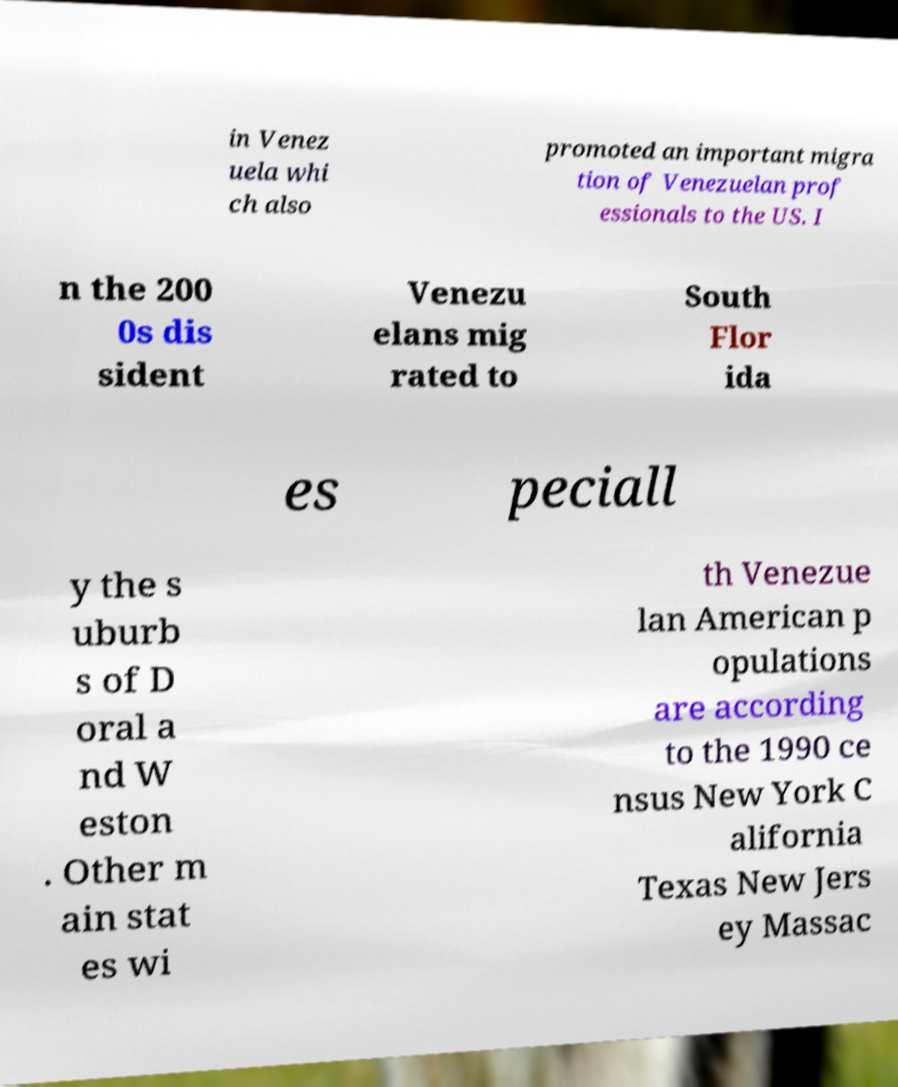What messages or text are displayed in this image? I need them in a readable, typed format. in Venez uela whi ch also promoted an important migra tion of Venezuelan prof essionals to the US. I n the 200 0s dis sident Venezu elans mig rated to South Flor ida es peciall y the s uburb s of D oral a nd W eston . Other m ain stat es wi th Venezue lan American p opulations are according to the 1990 ce nsus New York C alifornia Texas New Jers ey Massac 